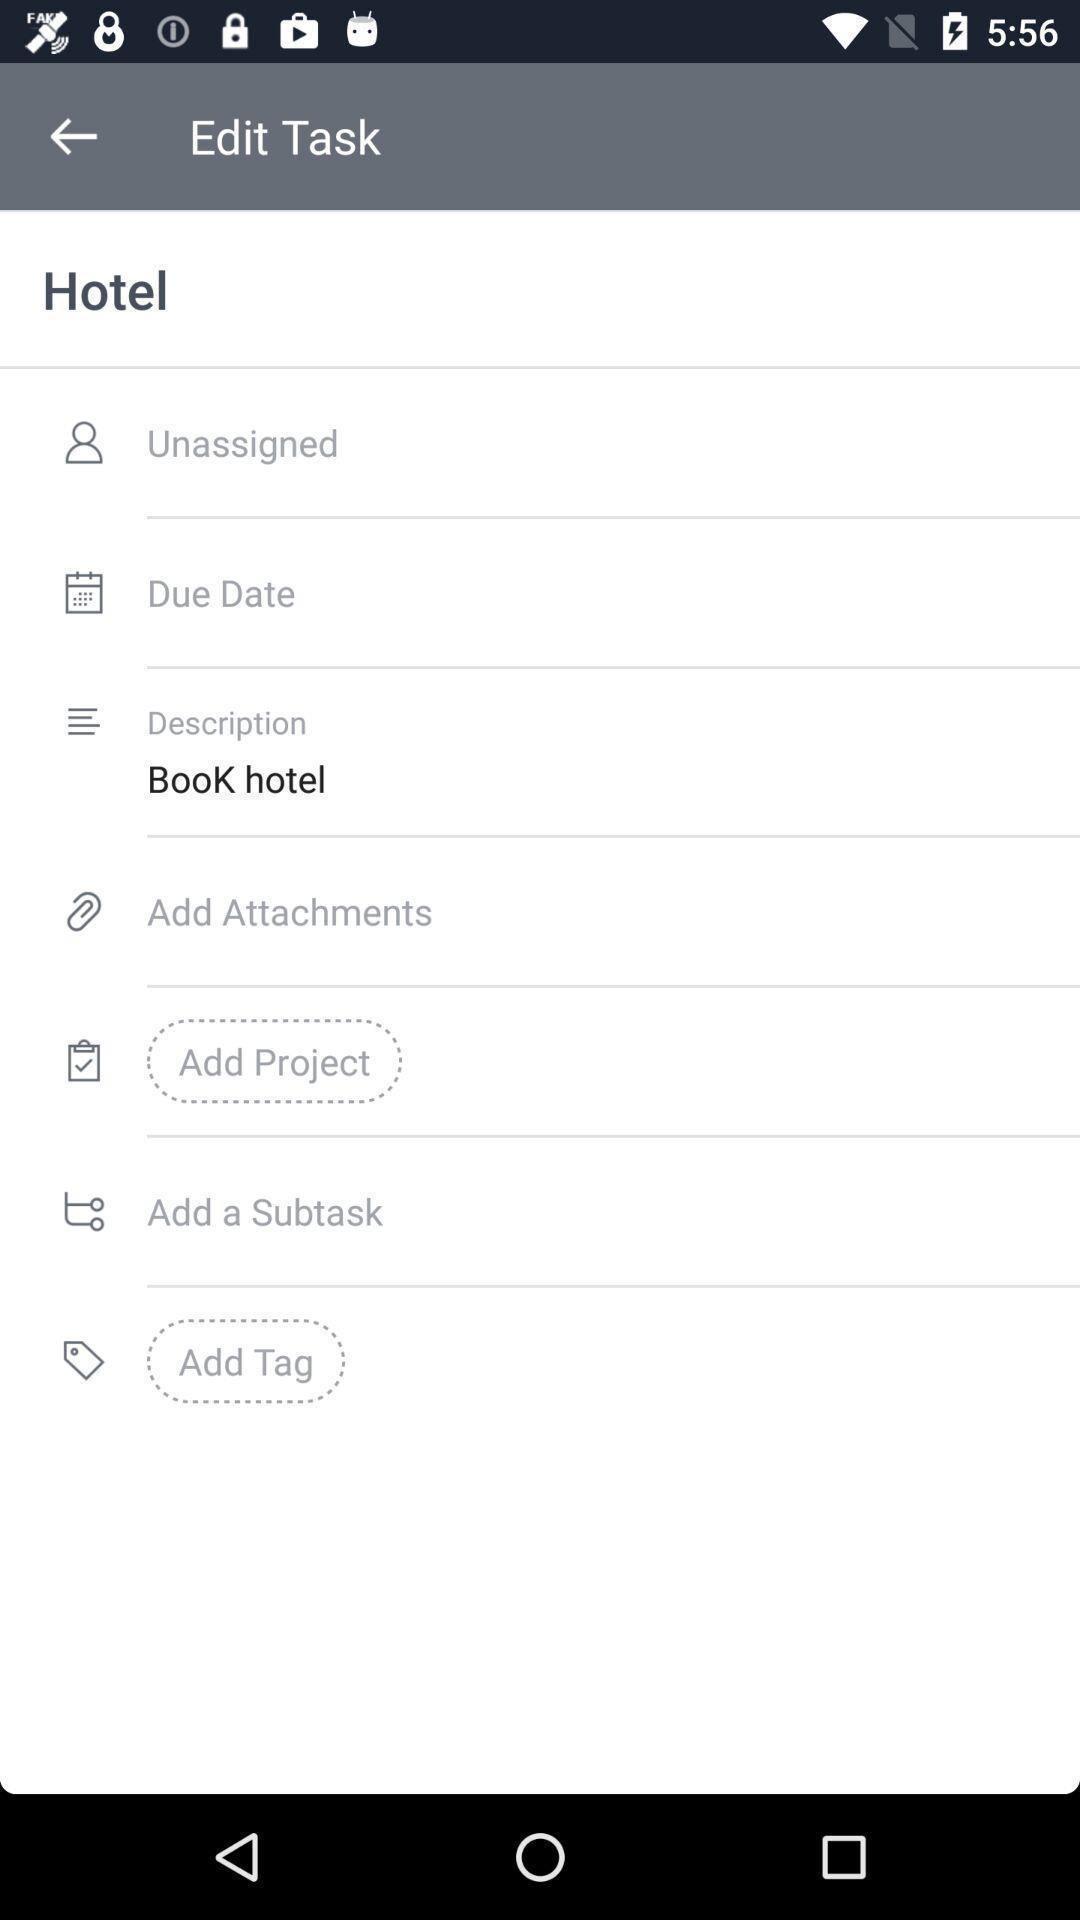Tell me what you see in this picture. Page displaying various options to edit a task. 